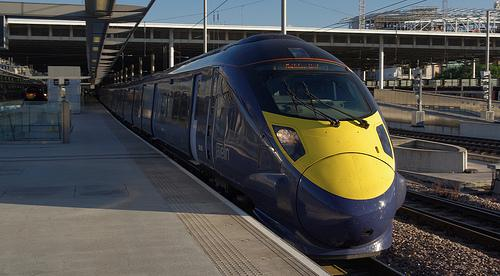Question: what color is the hood of the train?
Choices:
A. Red.
B. Blue.
C. Yellow.
D. Orange.
Answer with the letter. Answer: C Question: how many windshield wipers are on the train?
Choices:
A. One.
B. Three.
C. Two.
D. Four.
Answer with the letter. Answer: C Question: who , if anyone, is on the train platform?
Choices:
A. Two woman.
B. Three men.
C. Nobody.
D. An old lady.
Answer with the letter. Answer: C Question: where is the train relative to the platform?
Choices:
A. To the left.
B. To the right.
C. Ahead of it.
D. Next to it.
Answer with the letter. Answer: B Question: what color is the platform?
Choices:
A. Black.
B. Grey.
C. Brown.
D. White.
Answer with the letter. Answer: B 